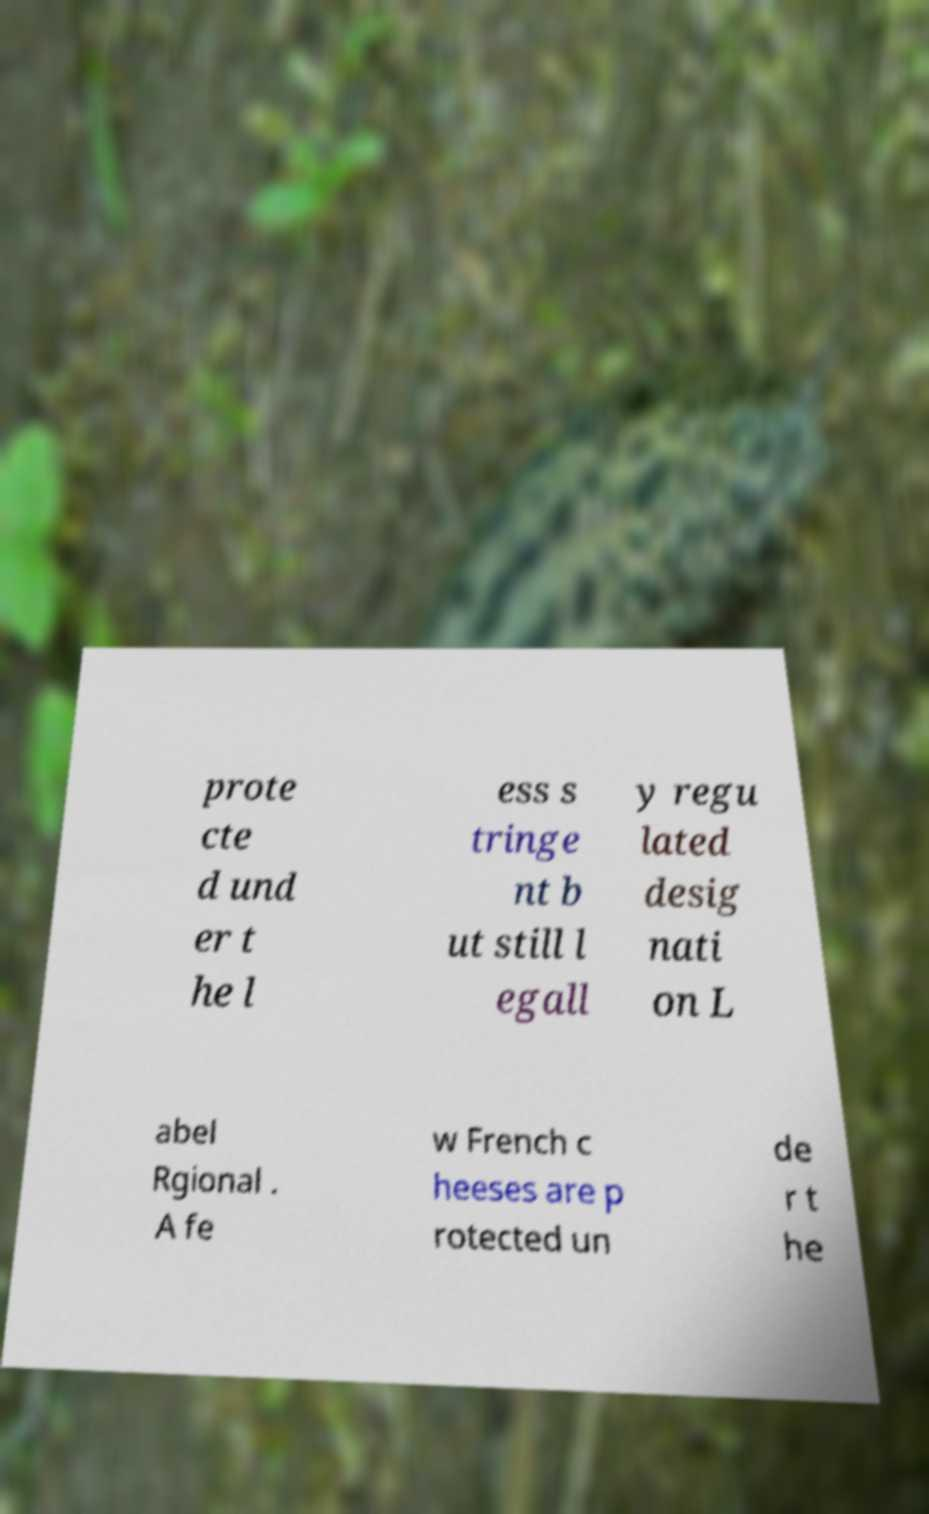What messages or text are displayed in this image? I need them in a readable, typed format. prote cte d und er t he l ess s tringe nt b ut still l egall y regu lated desig nati on L abel Rgional . A fe w French c heeses are p rotected un de r t he 